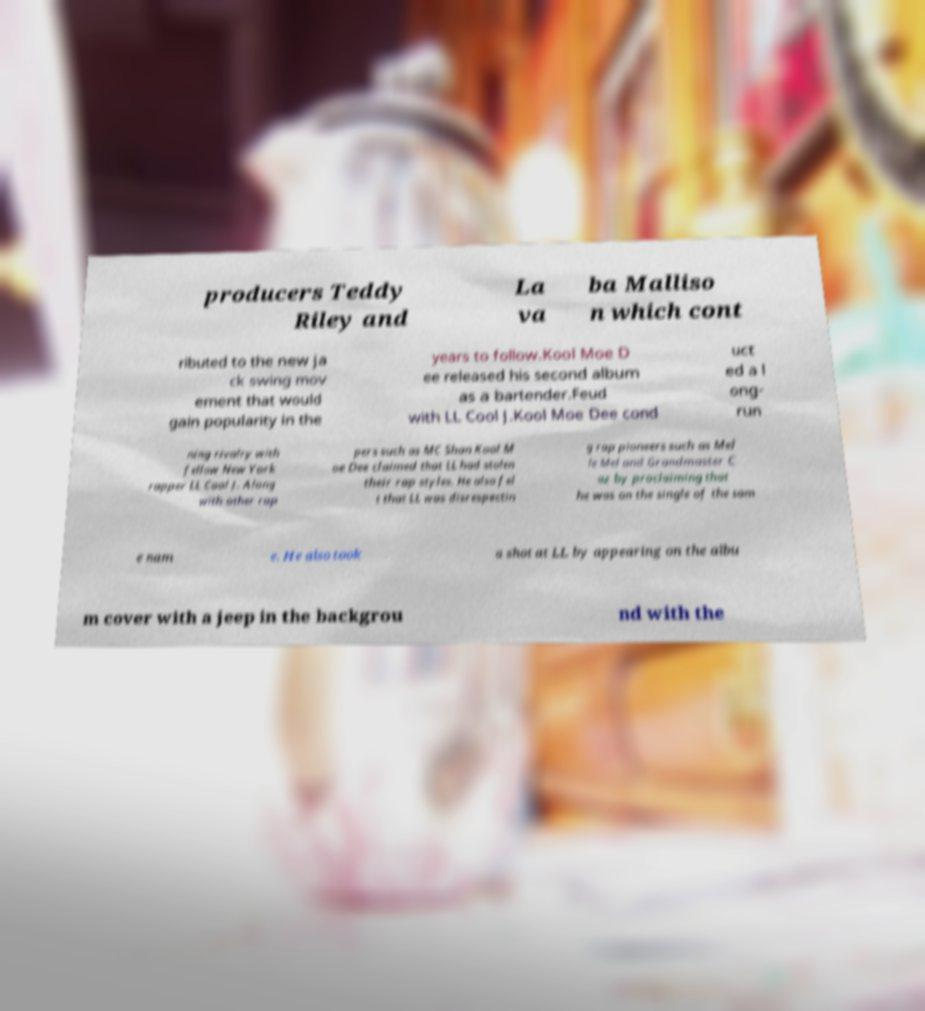For documentation purposes, I need the text within this image transcribed. Could you provide that? producers Teddy Riley and La va ba Malliso n which cont ributed to the new ja ck swing mov ement that would gain popularity in the years to follow.Kool Moe D ee released his second album as a bartender.Feud with LL Cool J.Kool Moe Dee cond uct ed a l ong- run ning rivalry with fellow New York rapper LL Cool J. Along with other rap pers such as MC Shan Kool M oe Dee claimed that LL had stolen their rap styles. He also fel t that LL was disrespectin g rap pioneers such as Mel le Mel and Grandmaster C az by proclaiming that he was on the single of the sam e nam e. He also took a shot at LL by appearing on the albu m cover with a jeep in the backgrou nd with the 